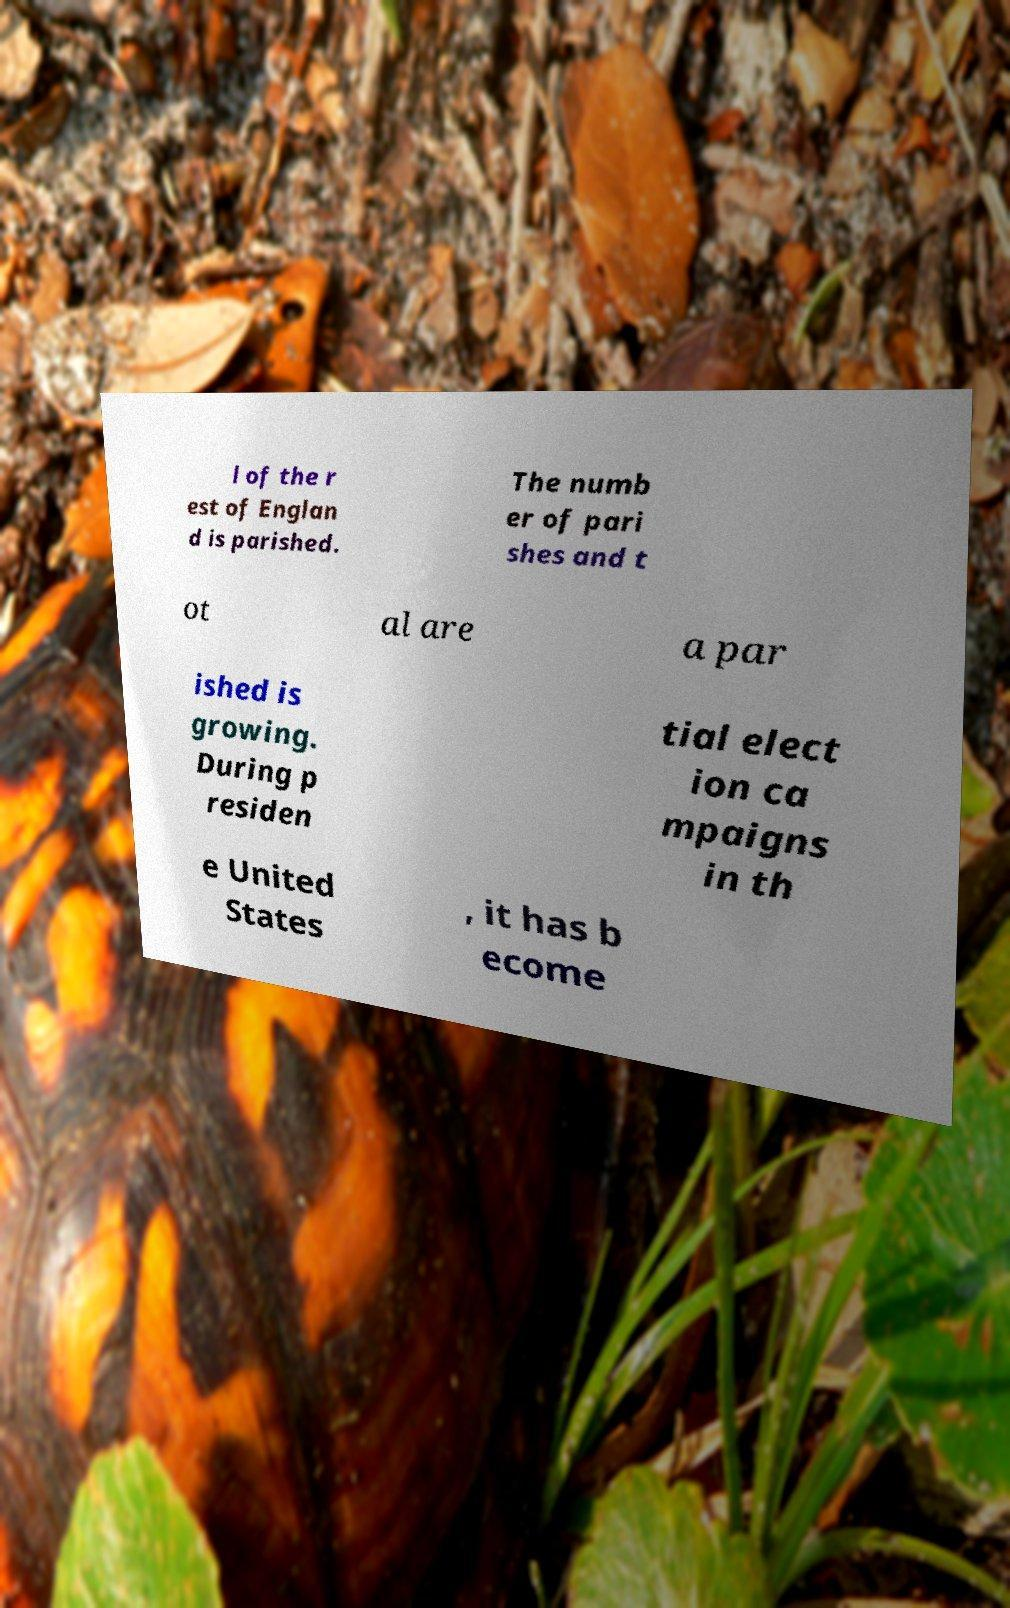Can you accurately transcribe the text from the provided image for me? l of the r est of Englan d is parished. The numb er of pari shes and t ot al are a par ished is growing. During p residen tial elect ion ca mpaigns in th e United States , it has b ecome 